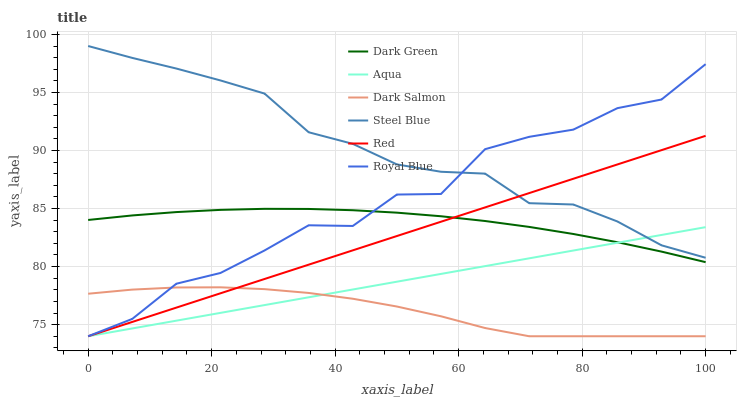Does Dark Salmon have the minimum area under the curve?
Answer yes or no. Yes. Does Steel Blue have the maximum area under the curve?
Answer yes or no. Yes. Does Steel Blue have the minimum area under the curve?
Answer yes or no. No. Does Dark Salmon have the maximum area under the curve?
Answer yes or no. No. Is Red the smoothest?
Answer yes or no. Yes. Is Royal Blue the roughest?
Answer yes or no. Yes. Is Steel Blue the smoothest?
Answer yes or no. No. Is Steel Blue the roughest?
Answer yes or no. No. Does Aqua have the lowest value?
Answer yes or no. Yes. Does Steel Blue have the lowest value?
Answer yes or no. No. Does Steel Blue have the highest value?
Answer yes or no. Yes. Does Dark Salmon have the highest value?
Answer yes or no. No. Is Dark Salmon less than Steel Blue?
Answer yes or no. Yes. Is Steel Blue greater than Dark Green?
Answer yes or no. Yes. Does Steel Blue intersect Aqua?
Answer yes or no. Yes. Is Steel Blue less than Aqua?
Answer yes or no. No. Is Steel Blue greater than Aqua?
Answer yes or no. No. Does Dark Salmon intersect Steel Blue?
Answer yes or no. No. 